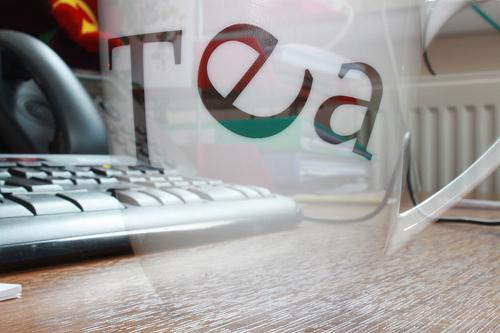Analyze the object interactions within the image. The white teacup with black tea letters is placed in front of the silver keyboard, which in turn is placed on a wooden desk alongside a black phone. What is the color of the keyboard in the image and what is it made of? The keyboard is black and grey in color and made of plastic material. Count the number of visible phones and mugs in the image. There is 1 phone and 1 mug visible in the image. Deduce insights from the complex reasoning task in the context of the image. The workspace's relaxed atmosphere, including the tea mug and other everyday work objects, might indicate that the individual working in this area values both comfort and productivity. Provide a brief description that summarizes the overall scene captured in the image. The image depicts a workspace setting with a wooden desk, a black and grey computer keyboard, a white teacup with the word 'tea', and a black corded telephone. Mention any instance of light reflection or glare in the image. There is a light glare visible on the black phone, possibly indicating a glass screen or a glossy surface. Comment on the quality of the image based on the visible objects and their clarity. The image quality seems to be decent with the objects having clear boundaries, although a few objects like the white teacup are partially transparent, and a wire shows through the image that can cause confusion. Describe the peculiar orientation of the letter 'e' in the image. The letter 'e' appears tilted on its side, giving it an artistic presentation. Comment on the image sentiment by analyzing the objects present. The scene looks like a casual workspace with a white teacup, a wooden desk, a black phone, and a black and grey keyboard, giving a sense of comfortable working atmosphere. Identify and describe the object that has the word "tea" written on it. A partially transparent white teacup with black tea letters on it, indicating it as a mug related to tea. 